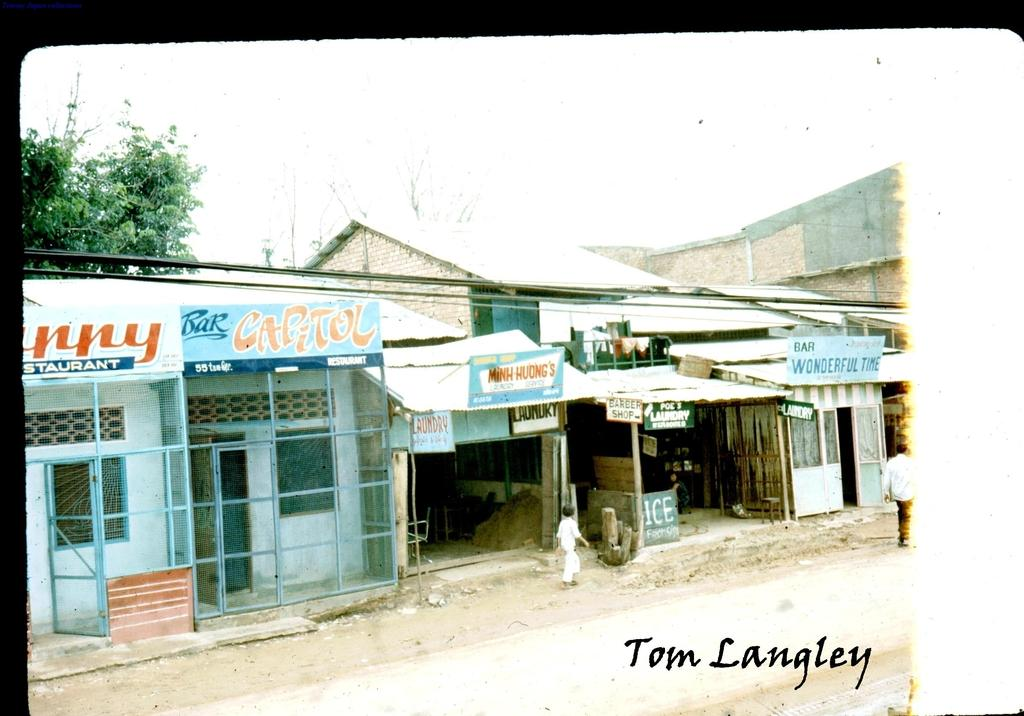What can be seen in the image besides the two persons on the road? In the background of the image, there are shops, boards, houses, trees, and the sky. What is the time of day when the image was taken? The image was taken during the day. What type of text is present in the image? The text in the image is not specified, but it is mentioned that there is text present. Can you see a camp in the image? There is no camp present in the image. Are the two persons on the road engaged in a fight? The image does not show any indication of a fight between the two persons on the road. 